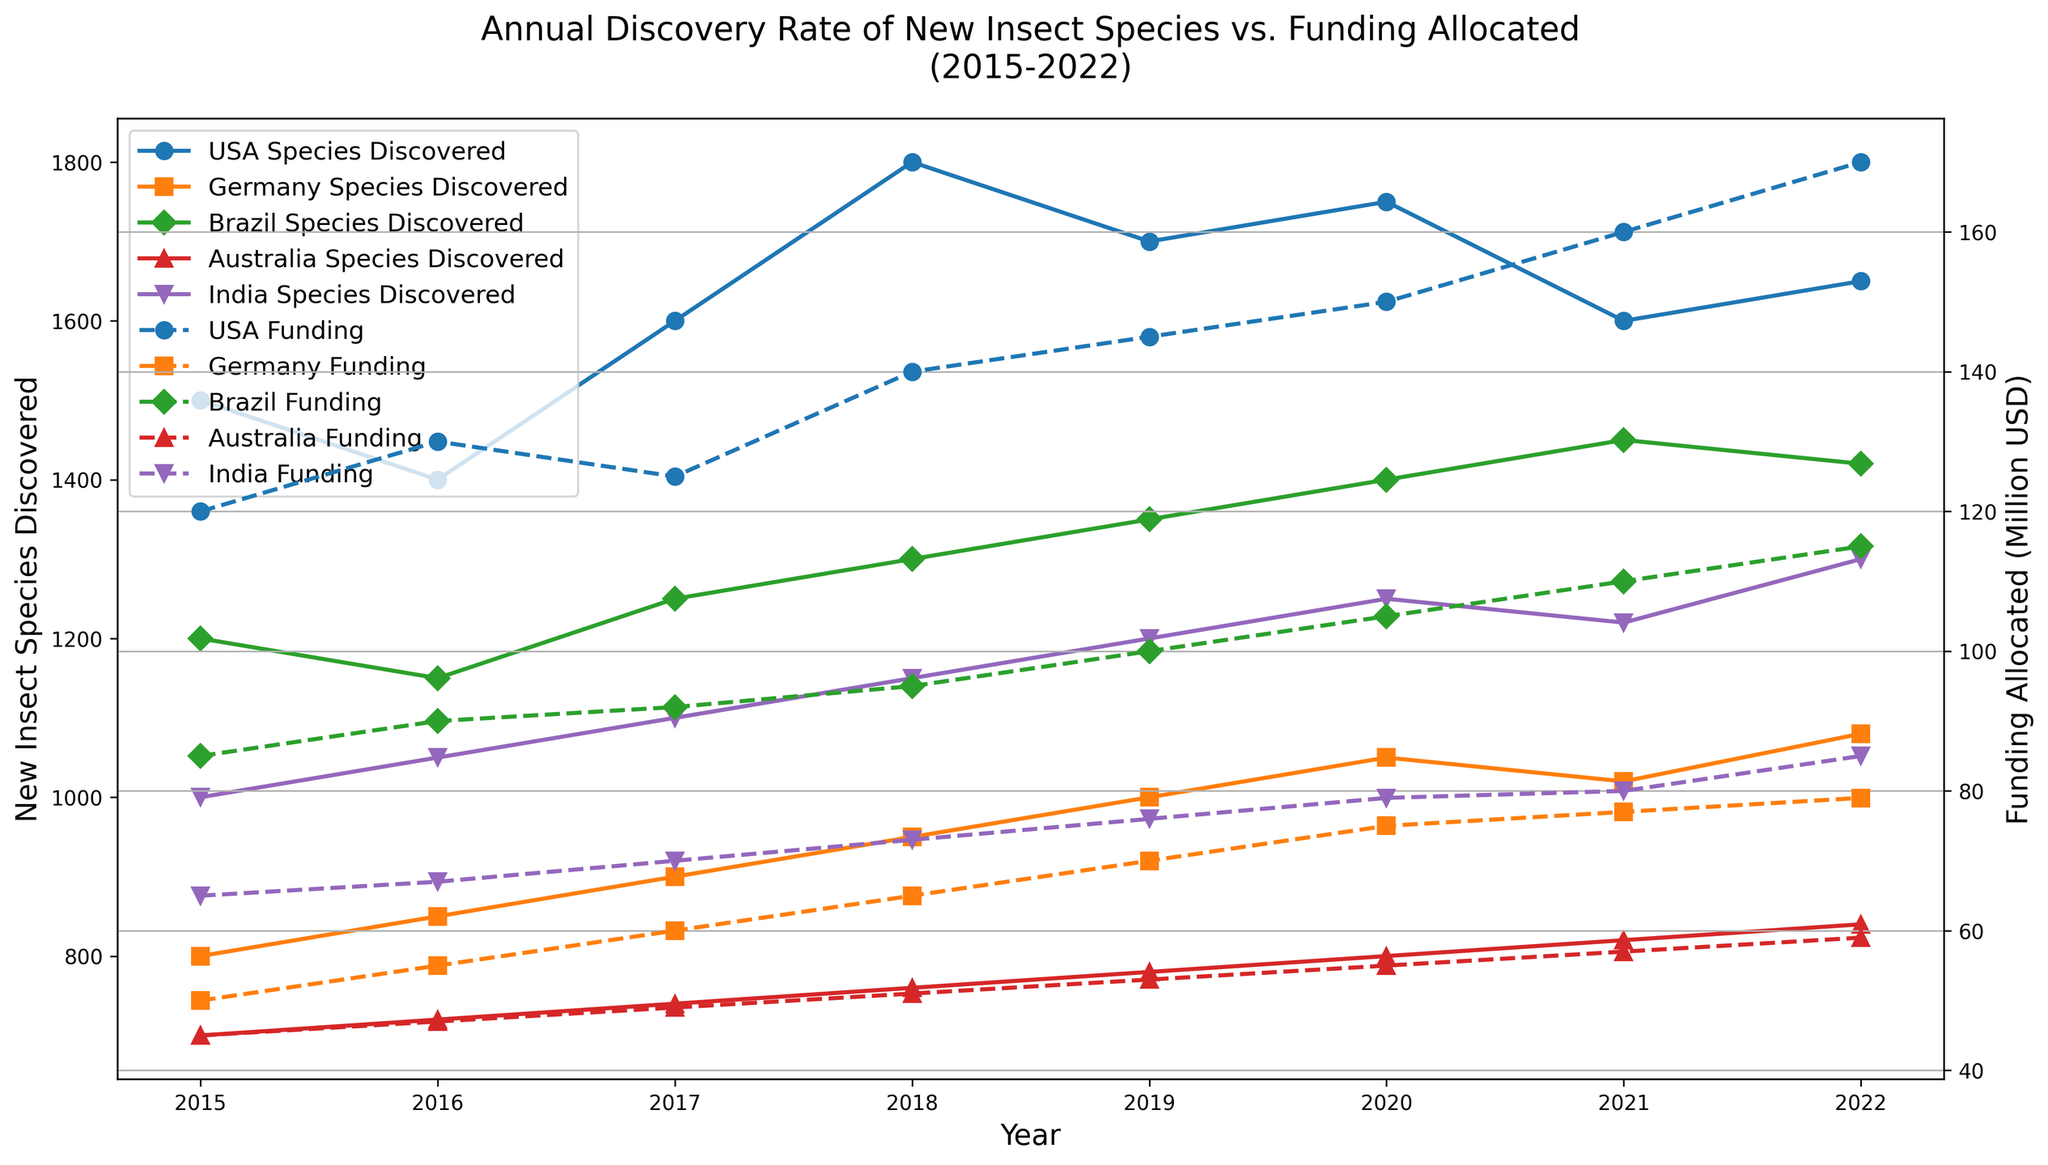Which country discovered the most new insect species in 2018? By looking at the plot for new insect species discovered in 2018, we find the country with the highest data point on the Y-axis for that year. USA has the highest point with 1800 species.
Answer: USA How did Germany's funding allocation change from 2015 to 2019? By observing the plot for Germany's funding allocation (dashed line) between 2015 and 2019, we can see that funding increased from $50 million in 2015 to $70 million in 2019. This can be seen by the ascending dashed line corresponding to Germany's color from 2015 to 2019.
Answer: Increased by $20 million Compare the discovery of new insect species between Brazil and India in 2020. Which country discovered more? We look at the plot for new insect species in 2020 for both Brazil and India. The data points for that year show Brazil with around 1400 species and India with around 1250 species.
Answer: Brazil What is the trend in funding allocation for Australia from 2015 to 2022? By following the dashed line corresponding to Australia from 2015 to 2022, the line shows a steady upward trend. This means that the funding for Australia has continuously increased each year within this period.
Answer: Increased In 2019, how much higher was the USA's funding compared to Brazil's funding? Observing the dashed lines for the USA and Brazil in 2019, the USA has $145 million allocated while Brazil has $100 million. The difference is $145 million - $100 million = $45 million.
Answer: $45 million Which country had the most fluctuations in new insect species discovered from 2015 to 2022? By observing the solid lines for each country, the USA shows the most fluctuations with noticeable increases and decreases in the discovery rate over the years, unlike other countries with more steady trends.
Answer: USA What was the total number of insect species discovered by Australia and Germany in 2021? Look at the solid lines for Australia and Germany in 2021. Australia discovered 820 species, and Germany discovered 1020 species. The total is 820 + 1020 = 1840 species.
Answer: 1840 species Compare the trends in funding allocations for India and Germany from 2018 to 2022. Which country showed a larger increase? Observing the dashed lines for India and Germany from 2018 to 2022, India's funding increased from $73 million to $85 million (a rise of $12 million), while Germany's funding increased from $65 million to $79 million (a rise of $14 million).
Answer: Germany How do the discovery rates for new insect species in the USA and Australia compare between 2018 and 2020? Reviewing the solid lines for the USA and Australia from 2018 to 2020, the USA's discovery rate shows an increase from 1800 to 1750 species, while Australia shows an increase from 760 to 800 species. The USA had higher rates but both countries showed positive growth.
Answer: USA had higher rates, both grew 